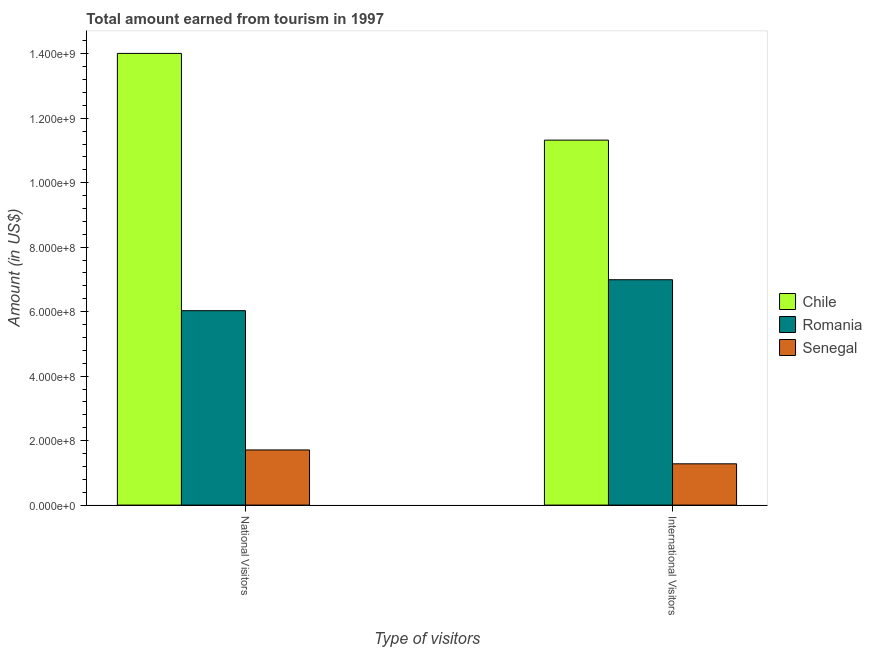How many different coloured bars are there?
Provide a short and direct response. 3. How many groups of bars are there?
Your answer should be compact. 2. How many bars are there on the 1st tick from the left?
Offer a terse response. 3. How many bars are there on the 2nd tick from the right?
Your response must be concise. 3. What is the label of the 1st group of bars from the left?
Make the answer very short. National Visitors. What is the amount earned from national visitors in Chile?
Your answer should be very brief. 1.40e+09. Across all countries, what is the maximum amount earned from national visitors?
Your response must be concise. 1.40e+09. Across all countries, what is the minimum amount earned from international visitors?
Offer a terse response. 1.28e+08. In which country was the amount earned from national visitors maximum?
Ensure brevity in your answer.  Chile. In which country was the amount earned from international visitors minimum?
Your answer should be very brief. Senegal. What is the total amount earned from national visitors in the graph?
Make the answer very short. 2.18e+09. What is the difference between the amount earned from international visitors in Romania and that in Senegal?
Offer a terse response. 5.71e+08. What is the difference between the amount earned from national visitors in Senegal and the amount earned from international visitors in Chile?
Offer a very short reply. -9.61e+08. What is the average amount earned from international visitors per country?
Offer a terse response. 6.53e+08. What is the difference between the amount earned from national visitors and amount earned from international visitors in Chile?
Make the answer very short. 2.69e+08. What is the ratio of the amount earned from national visitors in Senegal to that in Chile?
Your answer should be very brief. 0.12. Is the amount earned from national visitors in Chile less than that in Romania?
Keep it short and to the point. No. In how many countries, is the amount earned from international visitors greater than the average amount earned from international visitors taken over all countries?
Keep it short and to the point. 2. What does the 1st bar from the left in National Visitors represents?
Your response must be concise. Chile. What does the 1st bar from the right in National Visitors represents?
Provide a succinct answer. Senegal. What is the difference between two consecutive major ticks on the Y-axis?
Your answer should be compact. 2.00e+08. Are the values on the major ticks of Y-axis written in scientific E-notation?
Your response must be concise. Yes. Does the graph contain grids?
Provide a short and direct response. No. Where does the legend appear in the graph?
Your response must be concise. Center right. How are the legend labels stacked?
Your answer should be compact. Vertical. What is the title of the graph?
Give a very brief answer. Total amount earned from tourism in 1997. Does "Nepal" appear as one of the legend labels in the graph?
Keep it short and to the point. No. What is the label or title of the X-axis?
Keep it short and to the point. Type of visitors. What is the Amount (in US$) in Chile in National Visitors?
Ensure brevity in your answer.  1.40e+09. What is the Amount (in US$) of Romania in National Visitors?
Ensure brevity in your answer.  6.03e+08. What is the Amount (in US$) of Senegal in National Visitors?
Ensure brevity in your answer.  1.71e+08. What is the Amount (in US$) of Chile in International Visitors?
Keep it short and to the point. 1.13e+09. What is the Amount (in US$) of Romania in International Visitors?
Make the answer very short. 6.99e+08. What is the Amount (in US$) of Senegal in International Visitors?
Keep it short and to the point. 1.28e+08. Across all Type of visitors, what is the maximum Amount (in US$) in Chile?
Provide a succinct answer. 1.40e+09. Across all Type of visitors, what is the maximum Amount (in US$) of Romania?
Offer a terse response. 6.99e+08. Across all Type of visitors, what is the maximum Amount (in US$) in Senegal?
Your answer should be compact. 1.71e+08. Across all Type of visitors, what is the minimum Amount (in US$) of Chile?
Offer a terse response. 1.13e+09. Across all Type of visitors, what is the minimum Amount (in US$) of Romania?
Offer a very short reply. 6.03e+08. Across all Type of visitors, what is the minimum Amount (in US$) in Senegal?
Keep it short and to the point. 1.28e+08. What is the total Amount (in US$) of Chile in the graph?
Ensure brevity in your answer.  2.53e+09. What is the total Amount (in US$) of Romania in the graph?
Provide a succinct answer. 1.30e+09. What is the total Amount (in US$) of Senegal in the graph?
Offer a very short reply. 2.99e+08. What is the difference between the Amount (in US$) of Chile in National Visitors and that in International Visitors?
Provide a short and direct response. 2.69e+08. What is the difference between the Amount (in US$) in Romania in National Visitors and that in International Visitors?
Make the answer very short. -9.60e+07. What is the difference between the Amount (in US$) in Senegal in National Visitors and that in International Visitors?
Make the answer very short. 4.30e+07. What is the difference between the Amount (in US$) in Chile in National Visitors and the Amount (in US$) in Romania in International Visitors?
Offer a very short reply. 7.02e+08. What is the difference between the Amount (in US$) in Chile in National Visitors and the Amount (in US$) in Senegal in International Visitors?
Your response must be concise. 1.27e+09. What is the difference between the Amount (in US$) in Romania in National Visitors and the Amount (in US$) in Senegal in International Visitors?
Give a very brief answer. 4.75e+08. What is the average Amount (in US$) in Chile per Type of visitors?
Your response must be concise. 1.27e+09. What is the average Amount (in US$) in Romania per Type of visitors?
Your answer should be very brief. 6.51e+08. What is the average Amount (in US$) in Senegal per Type of visitors?
Your answer should be compact. 1.50e+08. What is the difference between the Amount (in US$) in Chile and Amount (in US$) in Romania in National Visitors?
Offer a terse response. 7.98e+08. What is the difference between the Amount (in US$) of Chile and Amount (in US$) of Senegal in National Visitors?
Your response must be concise. 1.23e+09. What is the difference between the Amount (in US$) in Romania and Amount (in US$) in Senegal in National Visitors?
Give a very brief answer. 4.32e+08. What is the difference between the Amount (in US$) in Chile and Amount (in US$) in Romania in International Visitors?
Your answer should be compact. 4.33e+08. What is the difference between the Amount (in US$) of Chile and Amount (in US$) of Senegal in International Visitors?
Your response must be concise. 1.00e+09. What is the difference between the Amount (in US$) of Romania and Amount (in US$) of Senegal in International Visitors?
Give a very brief answer. 5.71e+08. What is the ratio of the Amount (in US$) of Chile in National Visitors to that in International Visitors?
Provide a succinct answer. 1.24. What is the ratio of the Amount (in US$) of Romania in National Visitors to that in International Visitors?
Offer a very short reply. 0.86. What is the ratio of the Amount (in US$) of Senegal in National Visitors to that in International Visitors?
Your answer should be compact. 1.34. What is the difference between the highest and the second highest Amount (in US$) of Chile?
Provide a short and direct response. 2.69e+08. What is the difference between the highest and the second highest Amount (in US$) of Romania?
Give a very brief answer. 9.60e+07. What is the difference between the highest and the second highest Amount (in US$) in Senegal?
Your response must be concise. 4.30e+07. What is the difference between the highest and the lowest Amount (in US$) in Chile?
Provide a short and direct response. 2.69e+08. What is the difference between the highest and the lowest Amount (in US$) in Romania?
Your response must be concise. 9.60e+07. What is the difference between the highest and the lowest Amount (in US$) in Senegal?
Offer a very short reply. 4.30e+07. 